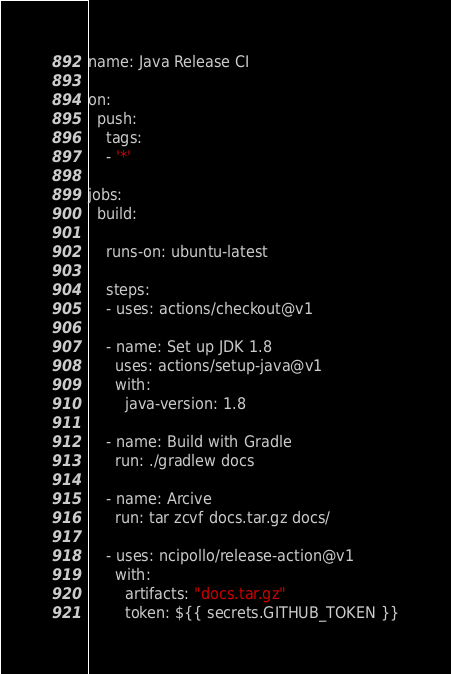<code> <loc_0><loc_0><loc_500><loc_500><_YAML_>name: Java Release CI

on: 
  push:
    tags:
    - '*'

jobs:
  build:

    runs-on: ubuntu-latest

    steps:
    - uses: actions/checkout@v1

    - name: Set up JDK 1.8
      uses: actions/setup-java@v1
      with:
        java-version: 1.8

    - name: Build with Gradle
      run: ./gradlew docs

    - name: Arcive
      run: tar zcvf docs.tar.gz docs/

    - uses: ncipollo/release-action@v1
      with:
        artifacts: "docs.tar.gz"
        token: ${{ secrets.GITHUB_TOKEN }}
</code> 